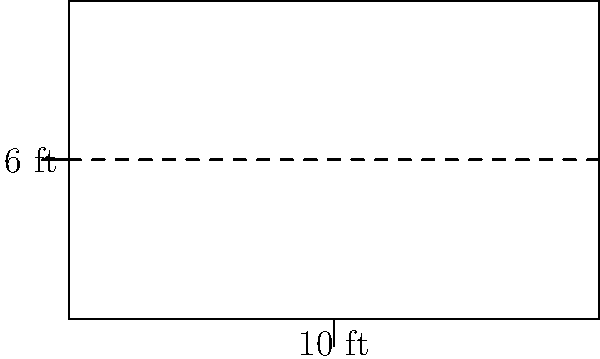You're designing a new rectangular horse stall for your prized stallion. The stall measures 10 feet in length and 6 feet in width. What is the total area of the stall in square feet? To find the area of a rectangular horse stall, we need to multiply its length by its width. Let's break it down step-by-step:

1. Identify the given dimensions:
   - Length = 10 feet
   - Width = 6 feet

2. Use the formula for the area of a rectangle:
   $$ A = L \times W $$
   Where $A$ is the area, $L$ is the length, and $W$ is the width.

3. Substitute the values into the formula:
   $$ A = 10 \text{ ft} \times 6 \text{ ft} $$

4. Perform the multiplication:
   $$ A = 60 \text{ ft}^2 $$

Therefore, the total area of the horse stall is 60 square feet.
Answer: 60 ft² 